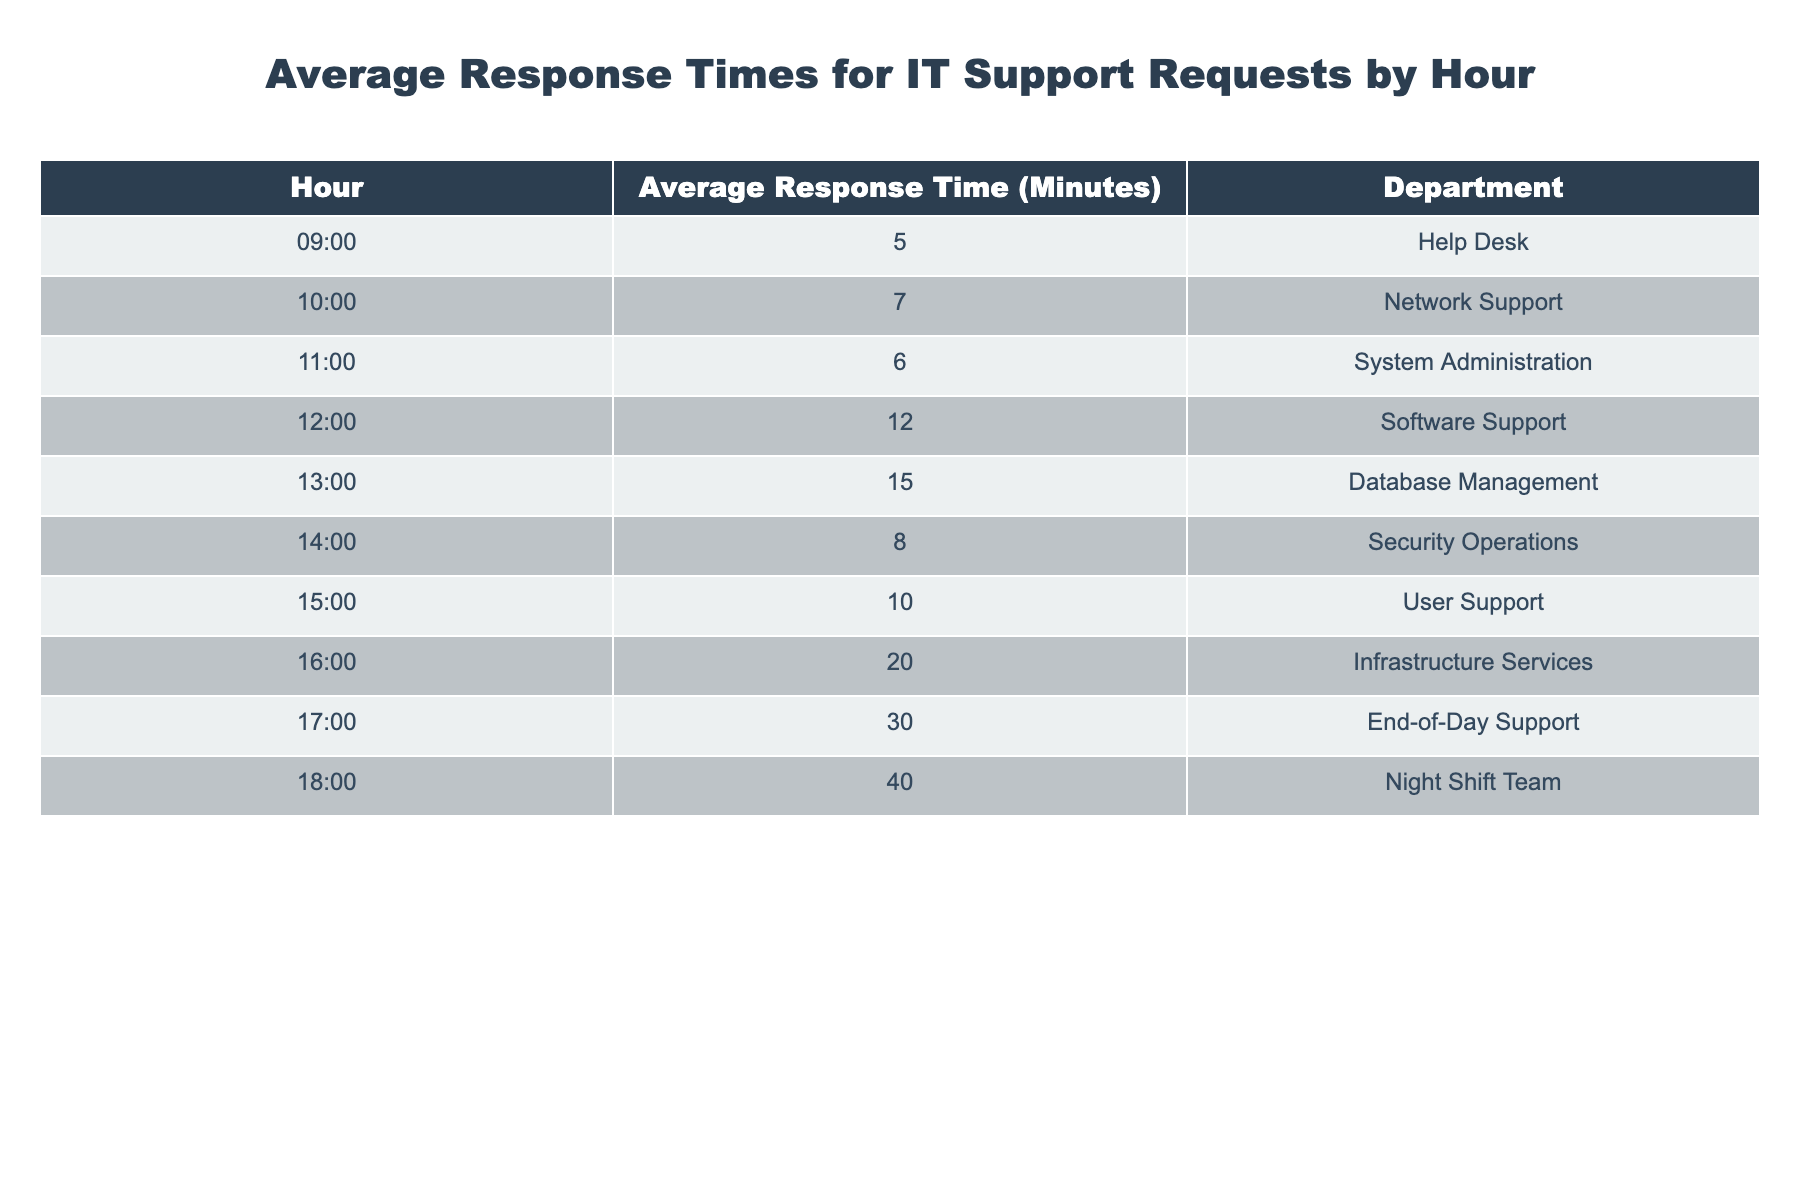What's the average response time for the Help Desk? The Help Desk's average response time is listed in the table under its respective hour. At 09:00, the table shows an average response time of 5 minutes for the Help Desk.
Answer: 5 Which department has the longest average response time? To find the longest average response time, we look through all the departments listed. The department with the highest average response time at 18:00 is the Night Shift Team with 40 minutes.
Answer: Night Shift Team What is the average response time between 9:00 and 12:00? To find the average response time between 9:00 and 12:00, we sum the response times for the Help Desk (5), Network Support (7), System Administration (6), and Software Support (12). This gives us 5 + 7 + 6 + 12 = 30. There are 4 data points, so we divide by 4: 30/4 = 7.5 minutes.
Answer: 7.5 Is the average response time for Database Management more than 20 minutes? The average response time for Database Management at 13:00 is specified in the table as 15 minutes. Since 15 is less than 20, the answer is no.
Answer: No What’s the difference in average response times between User Support and End-of-Day Support? We can find the average response times for both departments: User Support at 15:00 with 10 minutes, and End-of-Day Support at 17:00 with 30 minutes. We then subtract the times: 30 - 10 = 20 minutes.
Answer: 20 What is the total average response time for all departments from 9:00 to 17:00? From the table, we sum the average response times: Help Desk (5) + Network Support (7) + System Administration (6) + Software Support (12) + Database Management (15) + User Support (10) + End-of-Day Support (30) = 85 minutes. There are 7 departments, so we divide by 7 for the average: 85/7 ≈ 12.14 minutes.
Answer: Approximately 12.14 Which hour has the second-longest average response time? We examine the average response times in the table, listing them out. The longest is for the Night Shift Team at 40 minutes, and the second longest is for End-of-Day Support at 30 minutes, recorded at 17:00.
Answer: 17:00 Is the average response time for Security Operations less than 10 minutes? The table shows the average response time for Security Operations is 8 minutes at 14:00, which is less than 10 minutes. Therefore, the answer is yes.
Answer: Yes 